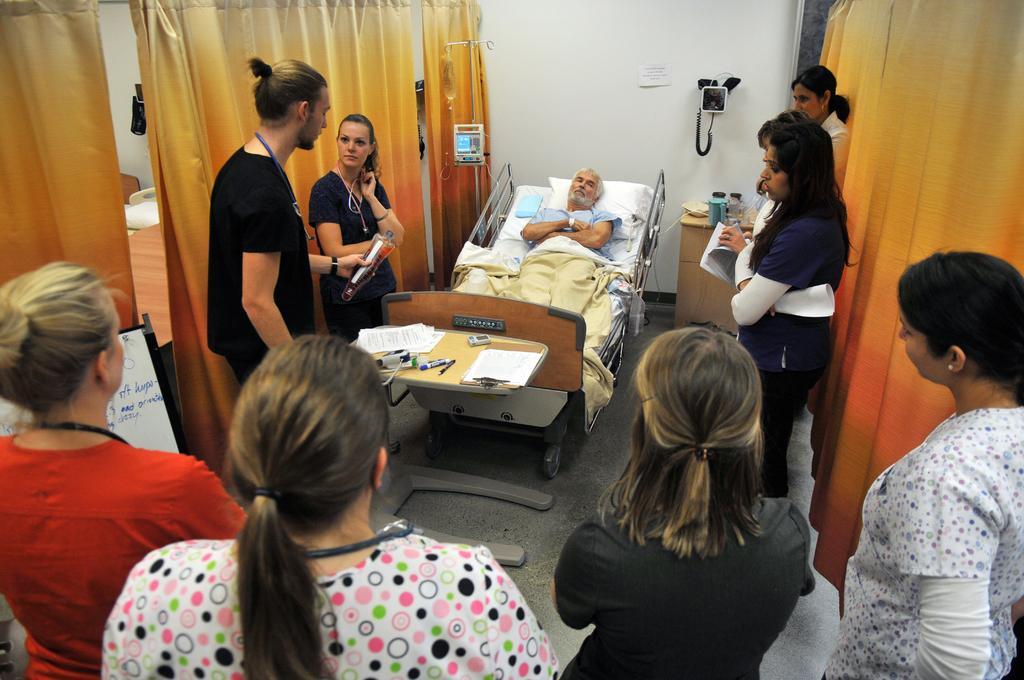In one or two sentences, can you explain what this image depicts? In this image, There is a inside view of a hospital. There are some people standing and wearing clothes. There is a person sleeping on the bed. This person holding a bottle with his hands. There are curtains behind this person. There is a table in front of this wall. 